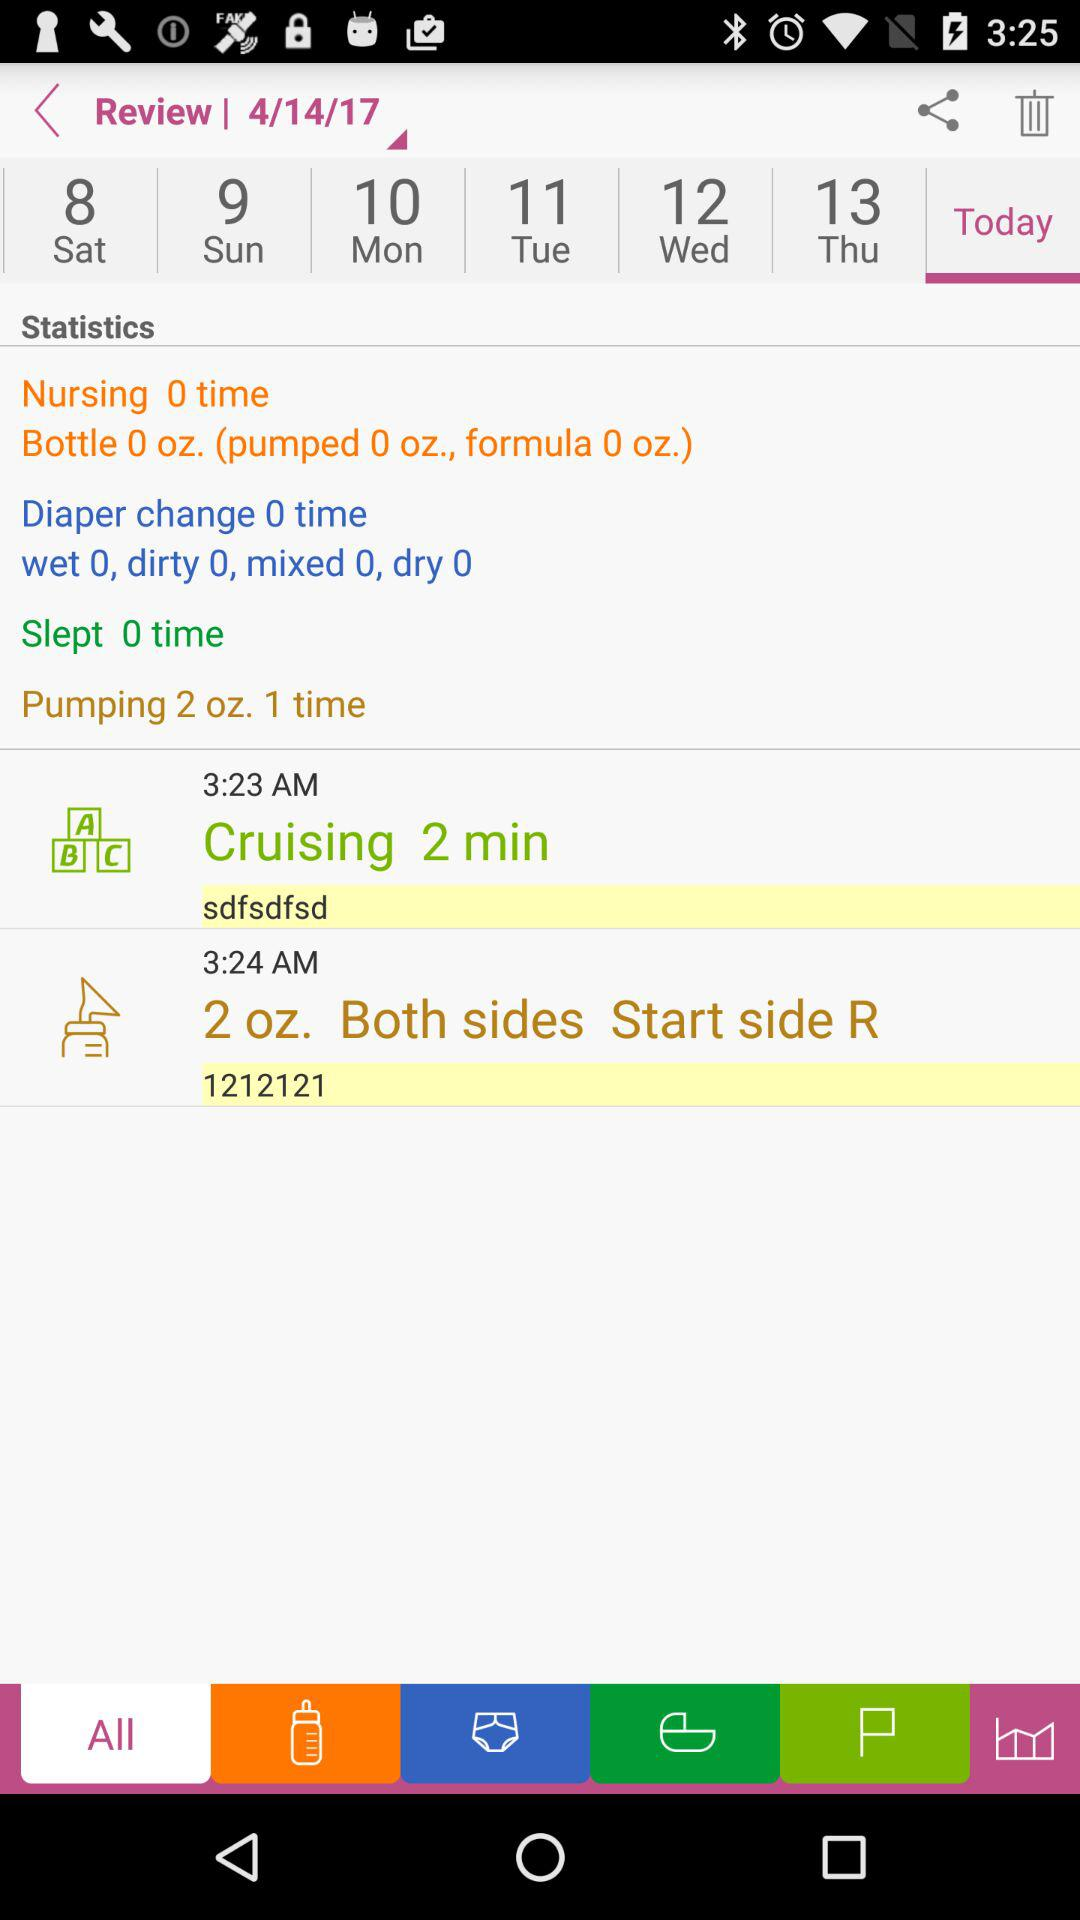How many times was nursing done? Nursing was done 0 times. 